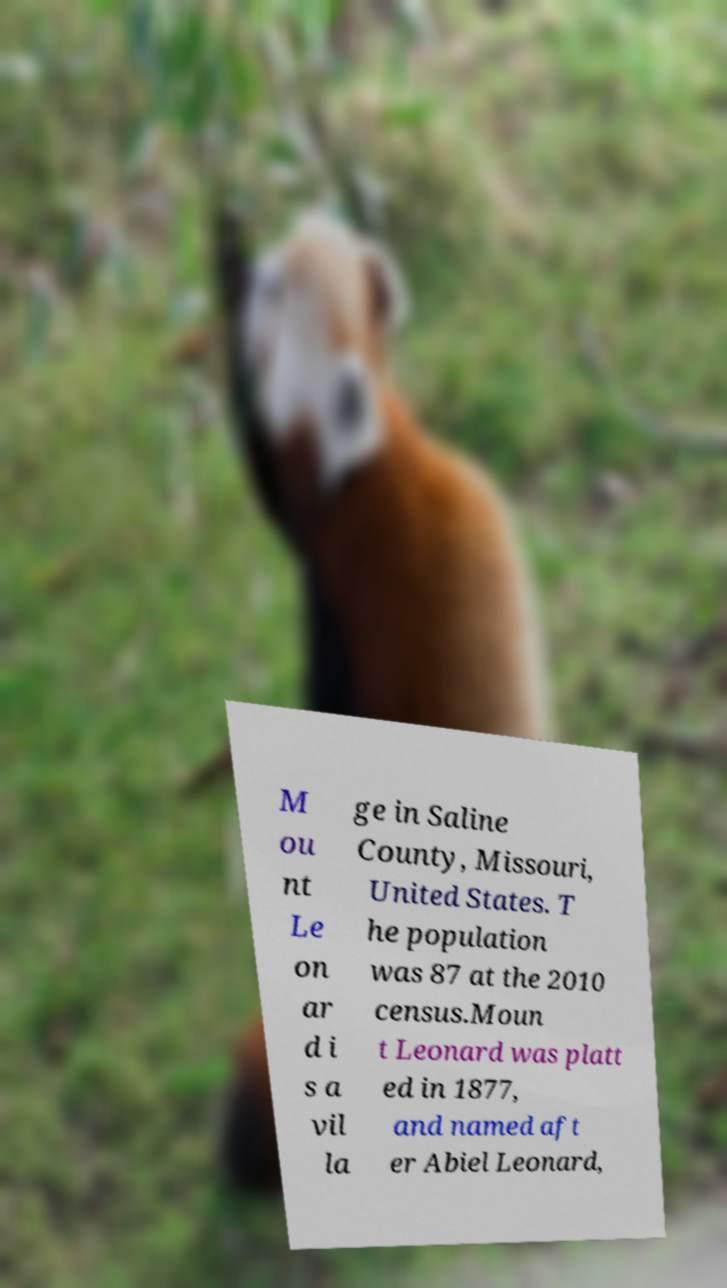Could you extract and type out the text from this image? M ou nt Le on ar d i s a vil la ge in Saline County, Missouri, United States. T he population was 87 at the 2010 census.Moun t Leonard was platt ed in 1877, and named aft er Abiel Leonard, 